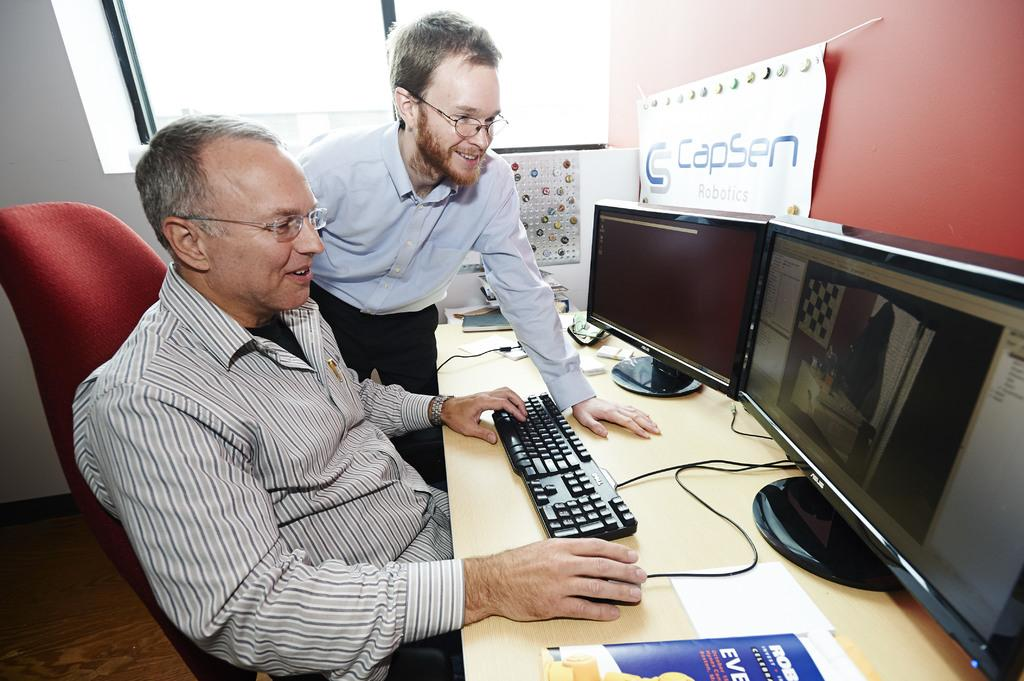<image>
Offer a succinct explanation of the picture presented. Two men looking at monitors, with a CapSen Robotics banner hanging on the wall near the monitors. 